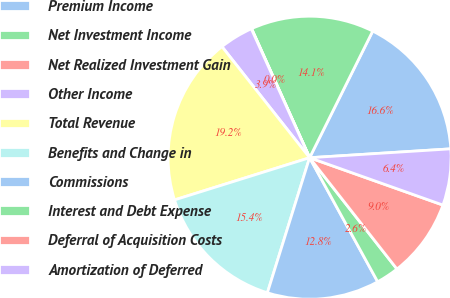Convert chart to OTSL. <chart><loc_0><loc_0><loc_500><loc_500><pie_chart><fcel>Premium Income<fcel>Net Investment Income<fcel>Net Realized Investment Gain<fcel>Other Income<fcel>Total Revenue<fcel>Benefits and Change in<fcel>Commissions<fcel>Interest and Debt Expense<fcel>Deferral of Acquisition Costs<fcel>Amortization of Deferred<nl><fcel>16.64%<fcel>14.08%<fcel>0.04%<fcel>3.87%<fcel>19.19%<fcel>15.36%<fcel>12.81%<fcel>2.6%<fcel>8.98%<fcel>6.43%<nl></chart> 